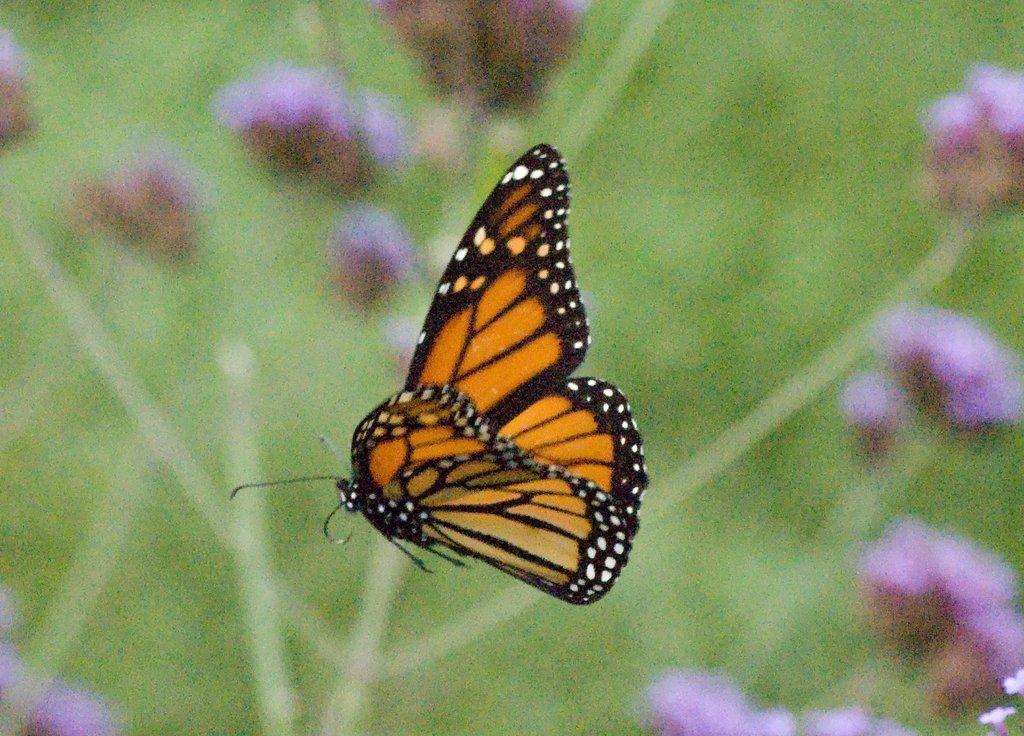Please provide a concise description of this image. In this image we can see a butterfly. In the background, we can see greenery and flowers. 